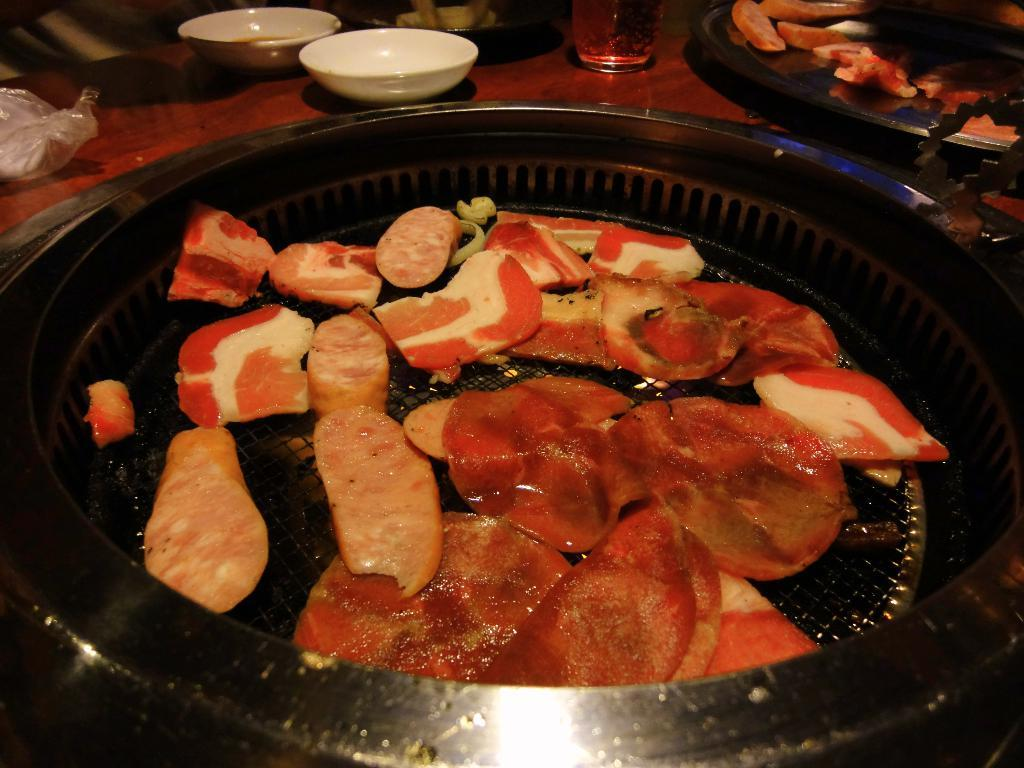What type of food items can be seen in the image? There are food items in plates in the image. What color are the bowls in the image? The bowls in the image are white. What type of container is present in the image? There is a glass in the image. What other objects can be seen on a surface in the image? There are some other objects visible on a surface in the image. Can you tell me how many cactus plants are on the table in the image? There are no cactus plants present in the image. What type of metal is used to make the utensils in the image? There is no information about the utensils or their material in the image. 